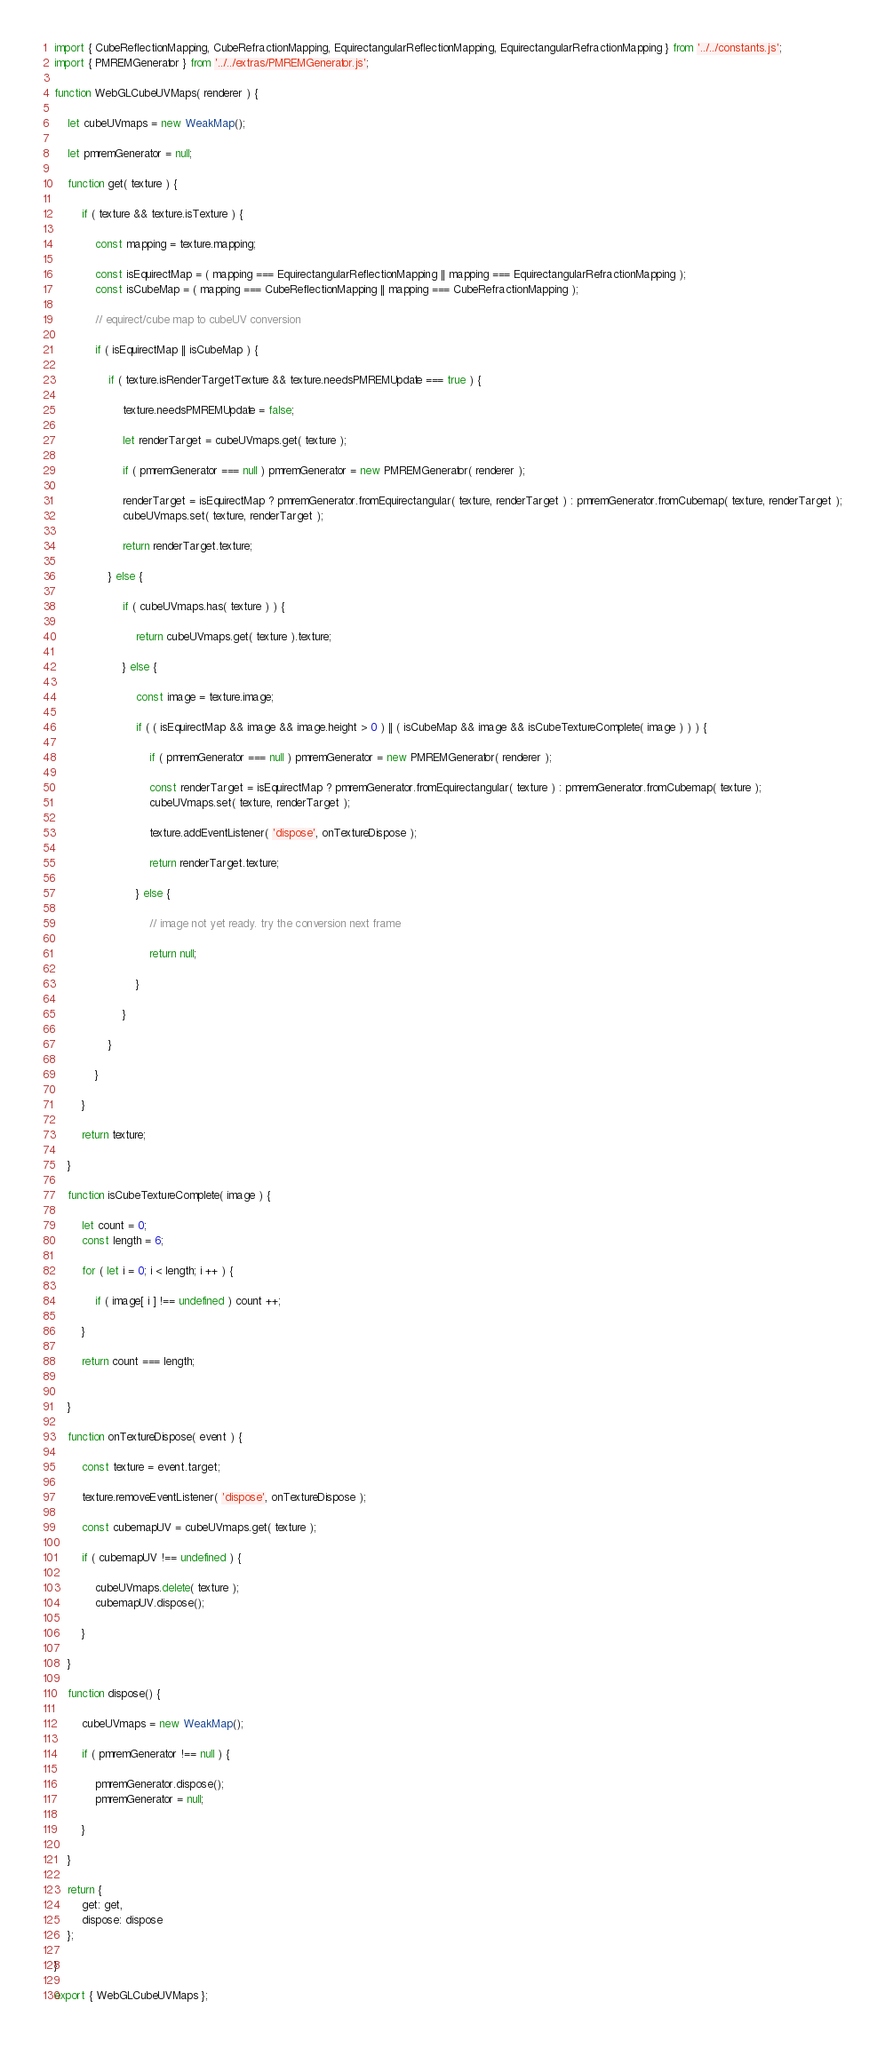<code> <loc_0><loc_0><loc_500><loc_500><_JavaScript_>import { CubeReflectionMapping, CubeRefractionMapping, EquirectangularReflectionMapping, EquirectangularRefractionMapping } from '../../constants.js';
import { PMREMGenerator } from '../../extras/PMREMGenerator.js';

function WebGLCubeUVMaps( renderer ) {

	let cubeUVmaps = new WeakMap();

	let pmremGenerator = null;

	function get( texture ) {

		if ( texture && texture.isTexture ) {

			const mapping = texture.mapping;

			const isEquirectMap = ( mapping === EquirectangularReflectionMapping || mapping === EquirectangularRefractionMapping );
			const isCubeMap = ( mapping === CubeReflectionMapping || mapping === CubeRefractionMapping );

			// equirect/cube map to cubeUV conversion

			if ( isEquirectMap || isCubeMap ) {

				if ( texture.isRenderTargetTexture && texture.needsPMREMUpdate === true ) {

					texture.needsPMREMUpdate = false;

					let renderTarget = cubeUVmaps.get( texture );

					if ( pmremGenerator === null ) pmremGenerator = new PMREMGenerator( renderer );

					renderTarget = isEquirectMap ? pmremGenerator.fromEquirectangular( texture, renderTarget ) : pmremGenerator.fromCubemap( texture, renderTarget );
					cubeUVmaps.set( texture, renderTarget );

					return renderTarget.texture;

				} else {

					if ( cubeUVmaps.has( texture ) ) {

						return cubeUVmaps.get( texture ).texture;

					} else {

						const image = texture.image;

						if ( ( isEquirectMap && image && image.height > 0 ) || ( isCubeMap && image && isCubeTextureComplete( image ) ) ) {

							if ( pmremGenerator === null ) pmremGenerator = new PMREMGenerator( renderer );

							const renderTarget = isEquirectMap ? pmremGenerator.fromEquirectangular( texture ) : pmremGenerator.fromCubemap( texture );
							cubeUVmaps.set( texture, renderTarget );

							texture.addEventListener( 'dispose', onTextureDispose );

							return renderTarget.texture;

						} else {

							// image not yet ready. try the conversion next frame

							return null;

						}

					}

				}

			}

		}

		return texture;

	}

	function isCubeTextureComplete( image ) {

		let count = 0;
		const length = 6;

		for ( let i = 0; i < length; i ++ ) {

			if ( image[ i ] !== undefined ) count ++;

		}

		return count === length;


	}

	function onTextureDispose( event ) {

		const texture = event.target;

		texture.removeEventListener( 'dispose', onTextureDispose );

		const cubemapUV = cubeUVmaps.get( texture );

		if ( cubemapUV !== undefined ) {

			cubeUVmaps.delete( texture );
			cubemapUV.dispose();

		}

	}

	function dispose() {

		cubeUVmaps = new WeakMap();

		if ( pmremGenerator !== null ) {

			pmremGenerator.dispose();
			pmremGenerator = null;

		}

	}

	return {
		get: get,
		dispose: dispose
	};

}

export { WebGLCubeUVMaps };
</code> 